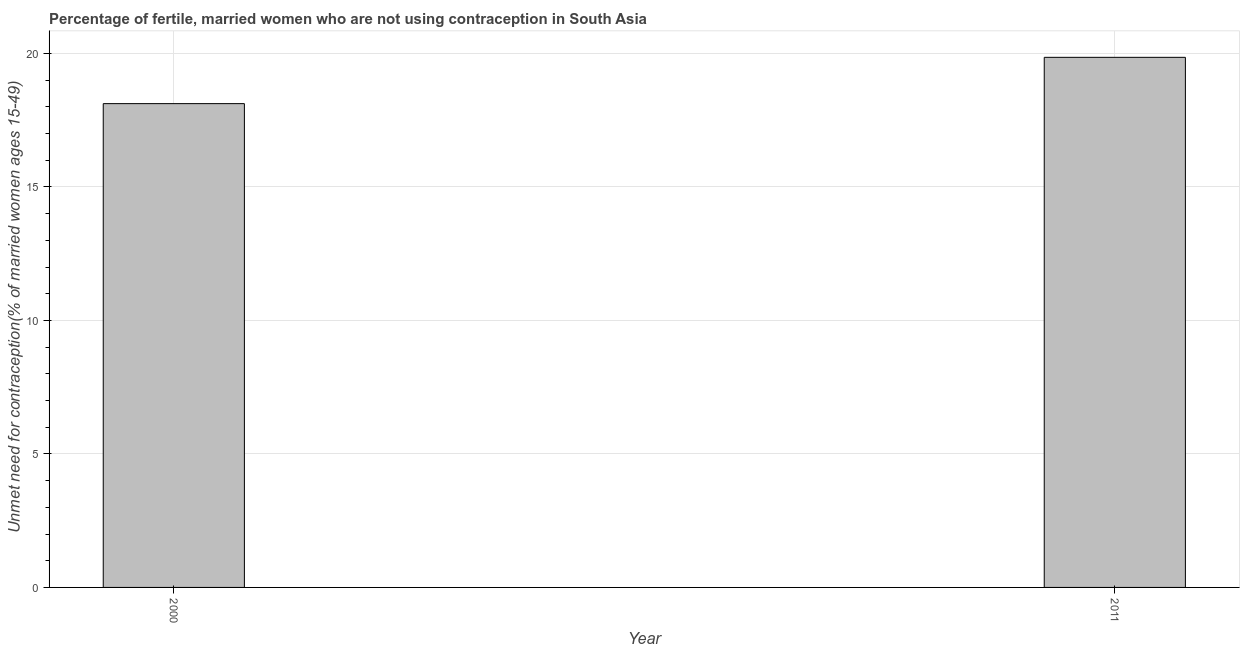Does the graph contain any zero values?
Provide a short and direct response. No. What is the title of the graph?
Ensure brevity in your answer.  Percentage of fertile, married women who are not using contraception in South Asia. What is the label or title of the Y-axis?
Your response must be concise.  Unmet need for contraception(% of married women ages 15-49). What is the number of married women who are not using contraception in 2000?
Offer a very short reply. 18.12. Across all years, what is the maximum number of married women who are not using contraception?
Your answer should be compact. 19.86. Across all years, what is the minimum number of married women who are not using contraception?
Provide a succinct answer. 18.12. What is the sum of the number of married women who are not using contraception?
Give a very brief answer. 37.98. What is the difference between the number of married women who are not using contraception in 2000 and 2011?
Ensure brevity in your answer.  -1.73. What is the average number of married women who are not using contraception per year?
Give a very brief answer. 18.99. What is the median number of married women who are not using contraception?
Provide a short and direct response. 18.99. In how many years, is the number of married women who are not using contraception greater than 15 %?
Offer a terse response. 2. Do a majority of the years between 2000 and 2011 (inclusive) have number of married women who are not using contraception greater than 14 %?
Give a very brief answer. Yes. What is the ratio of the number of married women who are not using contraception in 2000 to that in 2011?
Give a very brief answer. 0.91. In how many years, is the number of married women who are not using contraception greater than the average number of married women who are not using contraception taken over all years?
Your answer should be compact. 1. Are all the bars in the graph horizontal?
Keep it short and to the point. No. How many years are there in the graph?
Give a very brief answer. 2. What is the difference between two consecutive major ticks on the Y-axis?
Offer a very short reply. 5. What is the  Unmet need for contraception(% of married women ages 15-49) of 2000?
Give a very brief answer. 18.12. What is the  Unmet need for contraception(% of married women ages 15-49) of 2011?
Provide a succinct answer. 19.86. What is the difference between the  Unmet need for contraception(% of married women ages 15-49) in 2000 and 2011?
Your answer should be compact. -1.73. What is the ratio of the  Unmet need for contraception(% of married women ages 15-49) in 2000 to that in 2011?
Your answer should be compact. 0.91. 